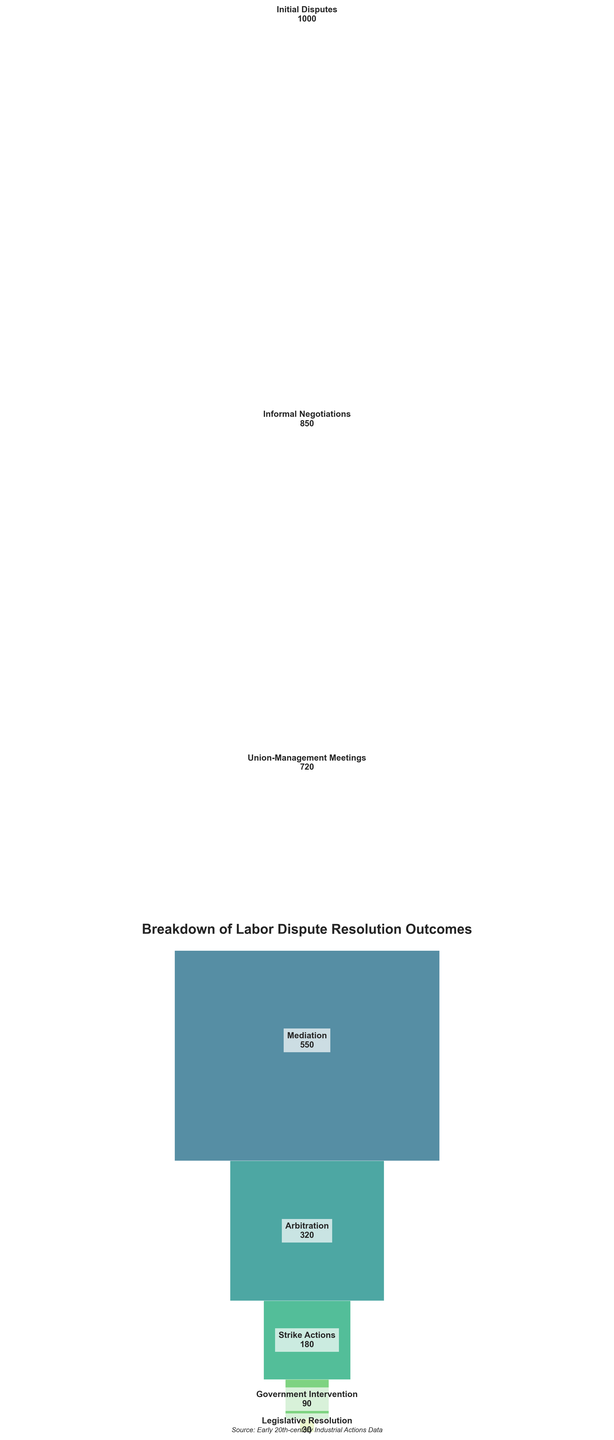What is the title of the funnel chart? The title of the funnel chart is prominently displayed at the top of the figure.
Answer: Breakdown of Labor Dispute Resolution Outcomes Which stage has the highest count of labor disputes? To determine the stage with the highest count, look at the first segment in the funnel chart as it represents the initial step in the resolution process.
Answer: Initial Disputes How many labor disputes reached the stage of Arbitration? Locate the segment labeled "Arbitration" and read the count associated with it.
Answer: 320 What is the difference between the number of disputes handled in Mediation and those that reached Government Intervention? First, find the counts for Mediation and Government Intervention, which are 550 and 90 respectively. Then, subtract the latter from the former: 550 - 90 = 460.
Answer: 460 What percentage of initial labor disputes were resolved by informal negotiations? First, locate the counts for Initial Disputes and Informal Negotiations, which are 1000 and 850 respectively. Then, compute the percentage: (850 / 1000) * 100 = 85%.
Answer: 85% Which stage shows the largest drop in the number of disputes from the previous stage? Calculate the difference in counts between consecutive stages and identify the largest decrease. The largest drop is between Mediation (550) and Arbitration (320), a difference of 230.
Answer: Mediation to Arbitration How many stages are depicted in the funnel chart? Count the number of distinct labeled segments in the funnel chart.
Answer: 8 What proportion of disputes that involved Strike Actions eventually led to Government Intervention? Find the counts for Strike Actions and Government Intervention, which are 180 and 90 respectively. Then, compute the proportion: 90 / 180 = 0.5 or 50%.
Answer: 50% What is the total number of disputes resolved at or before the Mediation stage? Sum the counts of all stages up to and including Mediation: 1000 (Initial Disputes) + 850 (Informal Negotiations) + 720 (Union-Management Meetings) + 550 (Mediation) = 3120.
Answer: 3120 What stage is directly above the Legislative Resolution? In a funnel chart, the segment directly above another represents the previous stage. Therefore, the stage directly above Legislative Resolution is Government Intervention.
Answer: Government Intervention 